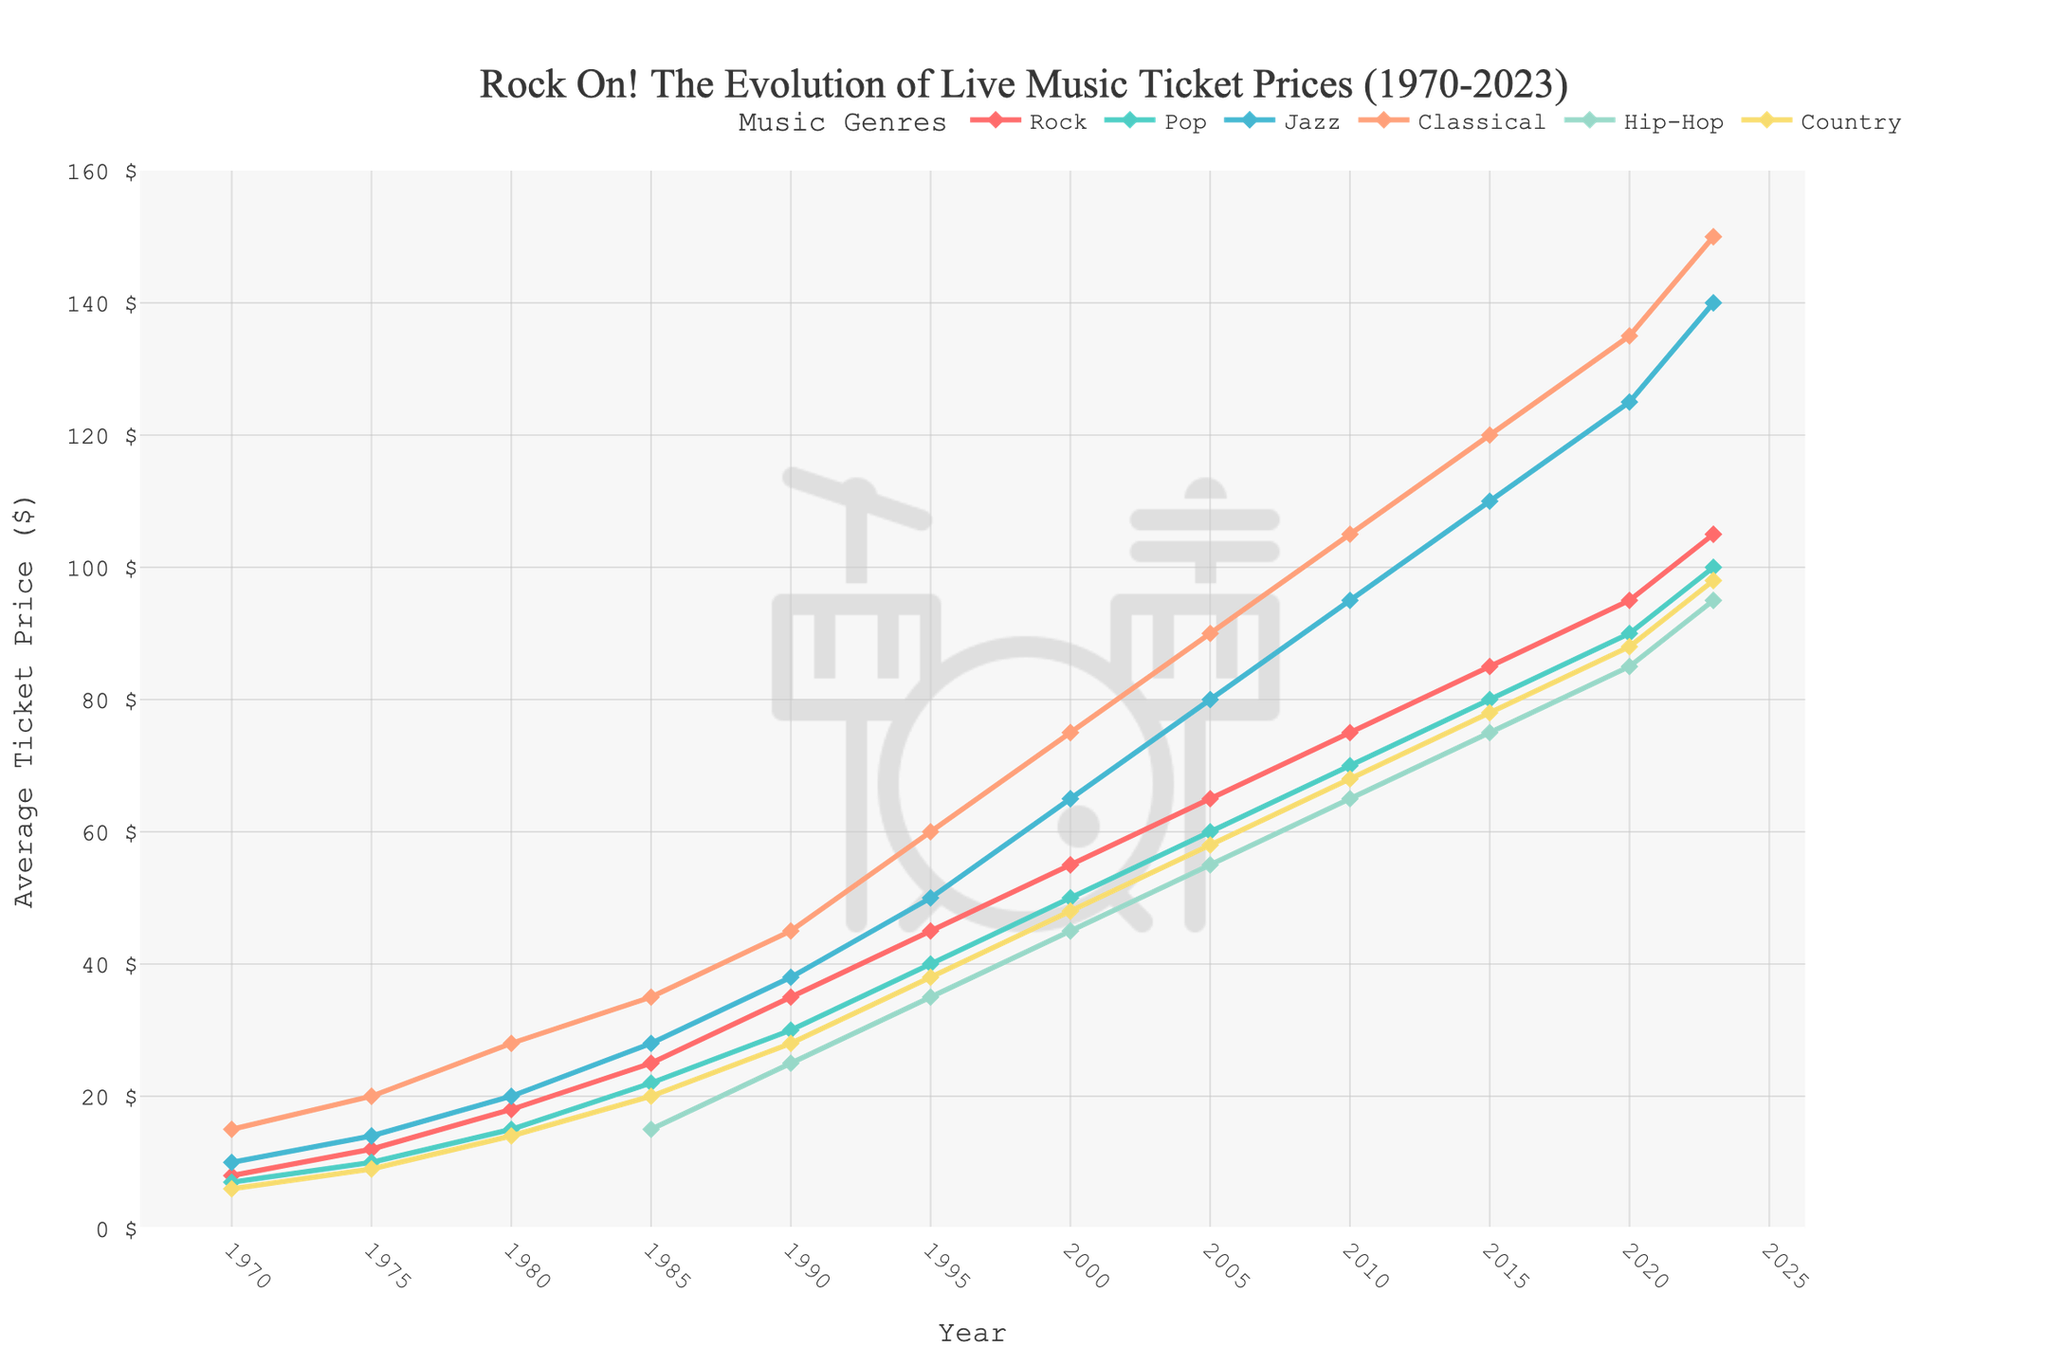What's the average ticket price for Rock concerts in the 1980s (1980 to 1989)? To find the average for the 1980s, identify the Rock ticket prices for 1980 (18) and 1985 (25). Average = (18+25) / 2 = 43 / 2
Answer: 21.5 How does the ticket price growth rate of Hip-Hop from 1990 to 2023 compare to that of Jazz? Calculate the change in ticket prices for Hip-Hop and Jazz between 1990 and 2023, then compare. Hip-Hop: 95 - 25 = 70; Jazz: 140 - 38 = 102. Jazz's change (102) is greater than Hip-Hop's (70).
Answer: Jazz greater than Hip-Hop Which genre had the highest ticket prices in 2000? Look up ticket prices for all genres in 2000. Rock: 55, Pop: 50, Jazz: 65, Classical: 75, Hip-Hop: 45, Country: 48. Classical has the highest ticket price (75).
Answer: Classical Between Pop and Country, which genre saw a higher price increase between 1970 and 2023, and by how much? Calculate the increases for both. Pop: 100 - 7 = 93, Country: 98 - 6 = 92. Difference: 93 - 92 = 1. Pop had a higher increase by 1 dollar.
Answer: Pop by 1 dollar In which year did Jazz ticket prices surpass $100? Look at the Jazz ticket prices data and find the first year they were over $100. This was in 2010 when the price was $105.
Answer: 2010 By how much did the average ticket price for Classical music increase per decade from 1970 to 2023? Compute the total increase and divide by the number of decades. Increase: 150 - 15 = 135. Number of decades: (2023-1970)/10 = 5.3. Average increase per decade: 135 / 5.3 ≈ 25.47.
Answer: 25.47 What is the visual indication that denotes markers for the ticket price data points? The markers are small diamond shapes positioned along the lines representing each genre's ticket prices.
Answer: Diamond shapes Which genre showed a consistently increasing trend in ticket prices from 1970 to 2023? By observing the chart, every genre shows an increase, but Classical has the most consistent upward trend with no dips.
Answer: Classical How much more expensive were Rock concert tickets compared to Country tickets in 2023? The 2023 prices are Rock: 105, Country: 98. Difference: 105 - 98 = 7.
Answer: 7 What color represents Pop concerts in the chart and what can you infer about its trends? Pop concerts are represented by a turquoise or teal color. The trend shows a steady increase from 1970 to 2023, rising sharply after the 1980s.
Answer: Turquoise/Teal, steady increase 